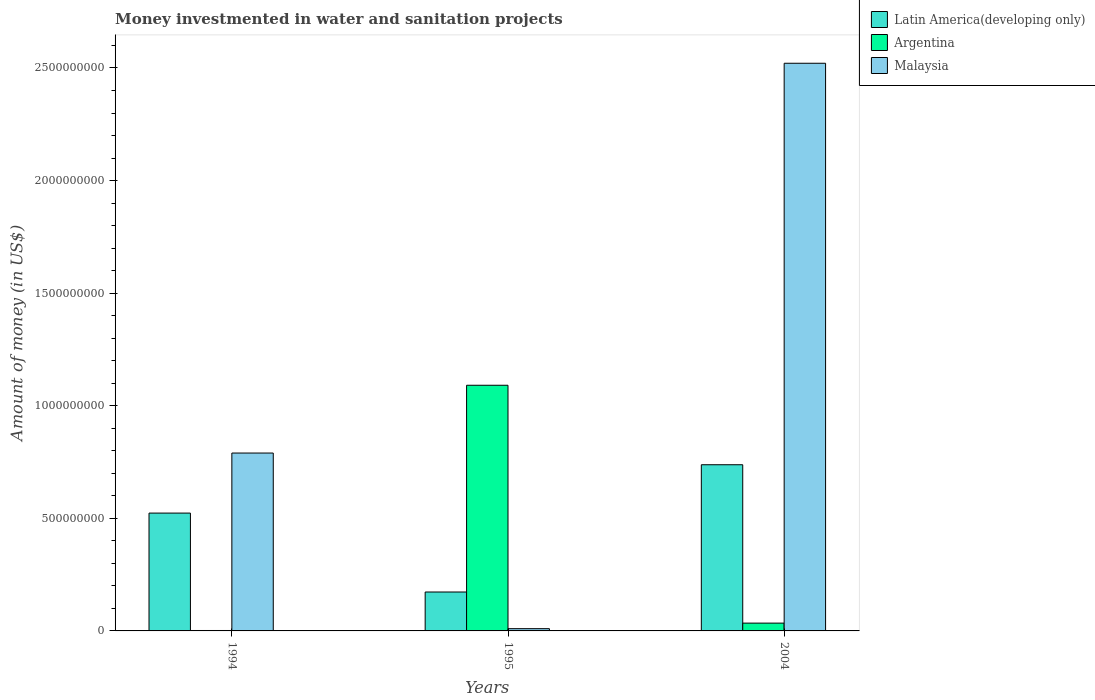How many different coloured bars are there?
Your response must be concise. 3. Are the number of bars on each tick of the X-axis equal?
Keep it short and to the point. Yes. How many bars are there on the 2nd tick from the left?
Keep it short and to the point. 3. What is the label of the 3rd group of bars from the left?
Keep it short and to the point. 2004. In how many cases, is the number of bars for a given year not equal to the number of legend labels?
Provide a succinct answer. 0. What is the money investmented in water and sanitation projects in Argentina in 1994?
Your answer should be compact. 1.90e+06. Across all years, what is the maximum money investmented in water and sanitation projects in Argentina?
Keep it short and to the point. 1.09e+09. Across all years, what is the minimum money investmented in water and sanitation projects in Malaysia?
Provide a succinct answer. 1.00e+07. In which year was the money investmented in water and sanitation projects in Malaysia maximum?
Offer a terse response. 2004. What is the total money investmented in water and sanitation projects in Malaysia in the graph?
Your answer should be very brief. 3.32e+09. What is the difference between the money investmented in water and sanitation projects in Malaysia in 1995 and that in 2004?
Offer a very short reply. -2.51e+09. What is the difference between the money investmented in water and sanitation projects in Malaysia in 1994 and the money investmented in water and sanitation projects in Argentina in 1995?
Your answer should be compact. -3.01e+08. What is the average money investmented in water and sanitation projects in Argentina per year?
Your response must be concise. 3.76e+08. In the year 1994, what is the difference between the money investmented in water and sanitation projects in Latin America(developing only) and money investmented in water and sanitation projects in Malaysia?
Make the answer very short. -2.67e+08. In how many years, is the money investmented in water and sanitation projects in Malaysia greater than 2100000000 US$?
Give a very brief answer. 1. What is the ratio of the money investmented in water and sanitation projects in Malaysia in 1994 to that in 1995?
Ensure brevity in your answer.  79. Is the difference between the money investmented in water and sanitation projects in Latin America(developing only) in 1994 and 1995 greater than the difference between the money investmented in water and sanitation projects in Malaysia in 1994 and 1995?
Offer a terse response. No. What is the difference between the highest and the second highest money investmented in water and sanitation projects in Latin America(developing only)?
Keep it short and to the point. 2.15e+08. What is the difference between the highest and the lowest money investmented in water and sanitation projects in Argentina?
Make the answer very short. 1.09e+09. In how many years, is the money investmented in water and sanitation projects in Latin America(developing only) greater than the average money investmented in water and sanitation projects in Latin America(developing only) taken over all years?
Provide a succinct answer. 2. Is the sum of the money investmented in water and sanitation projects in Argentina in 1994 and 2004 greater than the maximum money investmented in water and sanitation projects in Latin America(developing only) across all years?
Your answer should be compact. No. What does the 1st bar from the left in 1994 represents?
Give a very brief answer. Latin America(developing only). What does the 1st bar from the right in 1994 represents?
Your answer should be compact. Malaysia. Is it the case that in every year, the sum of the money investmented in water and sanitation projects in Latin America(developing only) and money investmented in water and sanitation projects in Argentina is greater than the money investmented in water and sanitation projects in Malaysia?
Your answer should be compact. No. Are all the bars in the graph horizontal?
Give a very brief answer. No. How many years are there in the graph?
Keep it short and to the point. 3. What is the difference between two consecutive major ticks on the Y-axis?
Your response must be concise. 5.00e+08. Does the graph contain grids?
Provide a succinct answer. No. Where does the legend appear in the graph?
Give a very brief answer. Top right. How are the legend labels stacked?
Make the answer very short. Vertical. What is the title of the graph?
Offer a very short reply. Money investmented in water and sanitation projects. Does "Italy" appear as one of the legend labels in the graph?
Keep it short and to the point. No. What is the label or title of the Y-axis?
Offer a terse response. Amount of money (in US$). What is the Amount of money (in US$) in Latin America(developing only) in 1994?
Your response must be concise. 5.23e+08. What is the Amount of money (in US$) of Argentina in 1994?
Your response must be concise. 1.90e+06. What is the Amount of money (in US$) of Malaysia in 1994?
Keep it short and to the point. 7.90e+08. What is the Amount of money (in US$) in Latin America(developing only) in 1995?
Keep it short and to the point. 1.73e+08. What is the Amount of money (in US$) of Argentina in 1995?
Your answer should be compact. 1.09e+09. What is the Amount of money (in US$) in Malaysia in 1995?
Your answer should be compact. 1.00e+07. What is the Amount of money (in US$) in Latin America(developing only) in 2004?
Your answer should be very brief. 7.38e+08. What is the Amount of money (in US$) of Argentina in 2004?
Make the answer very short. 3.46e+07. What is the Amount of money (in US$) of Malaysia in 2004?
Offer a terse response. 2.52e+09. Across all years, what is the maximum Amount of money (in US$) of Latin America(developing only)?
Offer a very short reply. 7.38e+08. Across all years, what is the maximum Amount of money (in US$) of Argentina?
Give a very brief answer. 1.09e+09. Across all years, what is the maximum Amount of money (in US$) of Malaysia?
Provide a short and direct response. 2.52e+09. Across all years, what is the minimum Amount of money (in US$) of Latin America(developing only)?
Keep it short and to the point. 1.73e+08. Across all years, what is the minimum Amount of money (in US$) in Argentina?
Your response must be concise. 1.90e+06. Across all years, what is the minimum Amount of money (in US$) of Malaysia?
Ensure brevity in your answer.  1.00e+07. What is the total Amount of money (in US$) in Latin America(developing only) in the graph?
Keep it short and to the point. 1.43e+09. What is the total Amount of money (in US$) in Argentina in the graph?
Offer a very short reply. 1.13e+09. What is the total Amount of money (in US$) in Malaysia in the graph?
Keep it short and to the point. 3.32e+09. What is the difference between the Amount of money (in US$) in Latin America(developing only) in 1994 and that in 1995?
Offer a terse response. 3.50e+08. What is the difference between the Amount of money (in US$) of Argentina in 1994 and that in 1995?
Offer a terse response. -1.09e+09. What is the difference between the Amount of money (in US$) in Malaysia in 1994 and that in 1995?
Offer a very short reply. 7.80e+08. What is the difference between the Amount of money (in US$) in Latin America(developing only) in 1994 and that in 2004?
Provide a succinct answer. -2.15e+08. What is the difference between the Amount of money (in US$) of Argentina in 1994 and that in 2004?
Offer a terse response. -3.28e+07. What is the difference between the Amount of money (in US$) in Malaysia in 1994 and that in 2004?
Keep it short and to the point. -1.73e+09. What is the difference between the Amount of money (in US$) of Latin America(developing only) in 1995 and that in 2004?
Provide a short and direct response. -5.65e+08. What is the difference between the Amount of money (in US$) in Argentina in 1995 and that in 2004?
Your answer should be compact. 1.06e+09. What is the difference between the Amount of money (in US$) of Malaysia in 1995 and that in 2004?
Your response must be concise. -2.51e+09. What is the difference between the Amount of money (in US$) of Latin America(developing only) in 1994 and the Amount of money (in US$) of Argentina in 1995?
Your response must be concise. -5.68e+08. What is the difference between the Amount of money (in US$) of Latin America(developing only) in 1994 and the Amount of money (in US$) of Malaysia in 1995?
Provide a short and direct response. 5.13e+08. What is the difference between the Amount of money (in US$) in Argentina in 1994 and the Amount of money (in US$) in Malaysia in 1995?
Offer a very short reply. -8.10e+06. What is the difference between the Amount of money (in US$) in Latin America(developing only) in 1994 and the Amount of money (in US$) in Argentina in 2004?
Offer a very short reply. 4.89e+08. What is the difference between the Amount of money (in US$) of Latin America(developing only) in 1994 and the Amount of money (in US$) of Malaysia in 2004?
Make the answer very short. -2.00e+09. What is the difference between the Amount of money (in US$) of Argentina in 1994 and the Amount of money (in US$) of Malaysia in 2004?
Make the answer very short. -2.52e+09. What is the difference between the Amount of money (in US$) of Latin America(developing only) in 1995 and the Amount of money (in US$) of Argentina in 2004?
Your response must be concise. 1.38e+08. What is the difference between the Amount of money (in US$) in Latin America(developing only) in 1995 and the Amount of money (in US$) in Malaysia in 2004?
Give a very brief answer. -2.35e+09. What is the difference between the Amount of money (in US$) of Argentina in 1995 and the Amount of money (in US$) of Malaysia in 2004?
Offer a terse response. -1.43e+09. What is the average Amount of money (in US$) of Latin America(developing only) per year?
Provide a succinct answer. 4.78e+08. What is the average Amount of money (in US$) of Argentina per year?
Give a very brief answer. 3.76e+08. What is the average Amount of money (in US$) in Malaysia per year?
Provide a succinct answer. 1.11e+09. In the year 1994, what is the difference between the Amount of money (in US$) of Latin America(developing only) and Amount of money (in US$) of Argentina?
Keep it short and to the point. 5.21e+08. In the year 1994, what is the difference between the Amount of money (in US$) in Latin America(developing only) and Amount of money (in US$) in Malaysia?
Keep it short and to the point. -2.67e+08. In the year 1994, what is the difference between the Amount of money (in US$) in Argentina and Amount of money (in US$) in Malaysia?
Your response must be concise. -7.88e+08. In the year 1995, what is the difference between the Amount of money (in US$) of Latin America(developing only) and Amount of money (in US$) of Argentina?
Provide a succinct answer. -9.18e+08. In the year 1995, what is the difference between the Amount of money (in US$) in Latin America(developing only) and Amount of money (in US$) in Malaysia?
Give a very brief answer. 1.63e+08. In the year 1995, what is the difference between the Amount of money (in US$) in Argentina and Amount of money (in US$) in Malaysia?
Your answer should be compact. 1.08e+09. In the year 2004, what is the difference between the Amount of money (in US$) in Latin America(developing only) and Amount of money (in US$) in Argentina?
Give a very brief answer. 7.03e+08. In the year 2004, what is the difference between the Amount of money (in US$) in Latin America(developing only) and Amount of money (in US$) in Malaysia?
Provide a succinct answer. -1.78e+09. In the year 2004, what is the difference between the Amount of money (in US$) in Argentina and Amount of money (in US$) in Malaysia?
Offer a very short reply. -2.49e+09. What is the ratio of the Amount of money (in US$) in Latin America(developing only) in 1994 to that in 1995?
Ensure brevity in your answer.  3.03. What is the ratio of the Amount of money (in US$) of Argentina in 1994 to that in 1995?
Keep it short and to the point. 0. What is the ratio of the Amount of money (in US$) in Malaysia in 1994 to that in 1995?
Provide a succinct answer. 79. What is the ratio of the Amount of money (in US$) of Latin America(developing only) in 1994 to that in 2004?
Your answer should be compact. 0.71. What is the ratio of the Amount of money (in US$) in Argentina in 1994 to that in 2004?
Make the answer very short. 0.05. What is the ratio of the Amount of money (in US$) of Malaysia in 1994 to that in 2004?
Offer a terse response. 0.31. What is the ratio of the Amount of money (in US$) in Latin America(developing only) in 1995 to that in 2004?
Offer a very short reply. 0.23. What is the ratio of the Amount of money (in US$) of Argentina in 1995 to that in 2004?
Ensure brevity in your answer.  31.49. What is the ratio of the Amount of money (in US$) in Malaysia in 1995 to that in 2004?
Offer a very short reply. 0. What is the difference between the highest and the second highest Amount of money (in US$) of Latin America(developing only)?
Your response must be concise. 2.15e+08. What is the difference between the highest and the second highest Amount of money (in US$) of Argentina?
Provide a short and direct response. 1.06e+09. What is the difference between the highest and the second highest Amount of money (in US$) of Malaysia?
Give a very brief answer. 1.73e+09. What is the difference between the highest and the lowest Amount of money (in US$) in Latin America(developing only)?
Your response must be concise. 5.65e+08. What is the difference between the highest and the lowest Amount of money (in US$) in Argentina?
Your answer should be very brief. 1.09e+09. What is the difference between the highest and the lowest Amount of money (in US$) in Malaysia?
Offer a very short reply. 2.51e+09. 